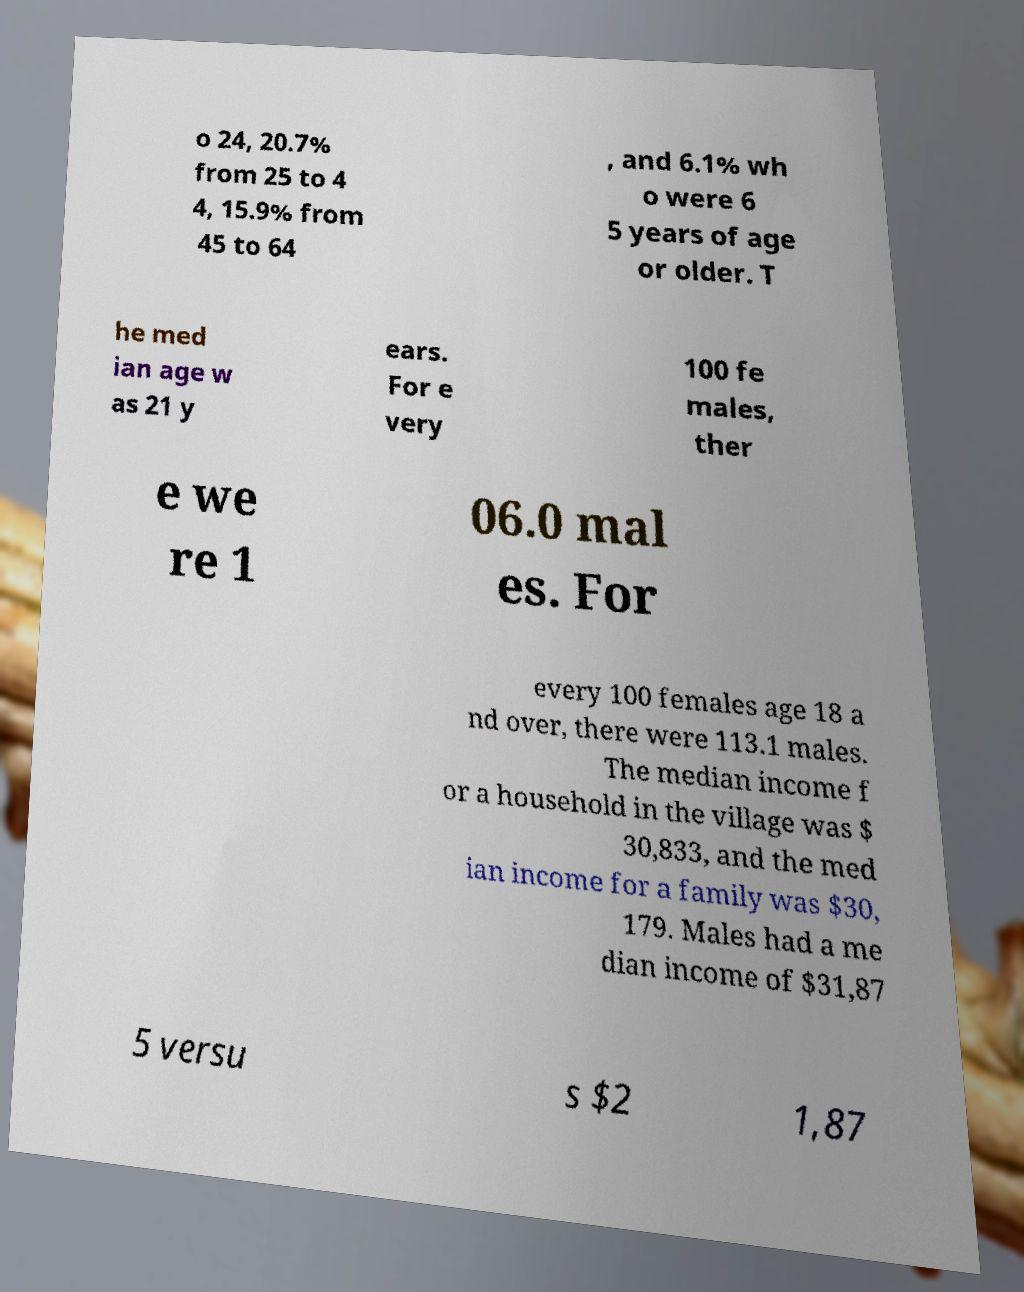For documentation purposes, I need the text within this image transcribed. Could you provide that? o 24, 20.7% from 25 to 4 4, 15.9% from 45 to 64 , and 6.1% wh o were 6 5 years of age or older. T he med ian age w as 21 y ears. For e very 100 fe males, ther e we re 1 06.0 mal es. For every 100 females age 18 a nd over, there were 113.1 males. The median income f or a household in the village was $ 30,833, and the med ian income for a family was $30, 179. Males had a me dian income of $31,87 5 versu s $2 1,87 